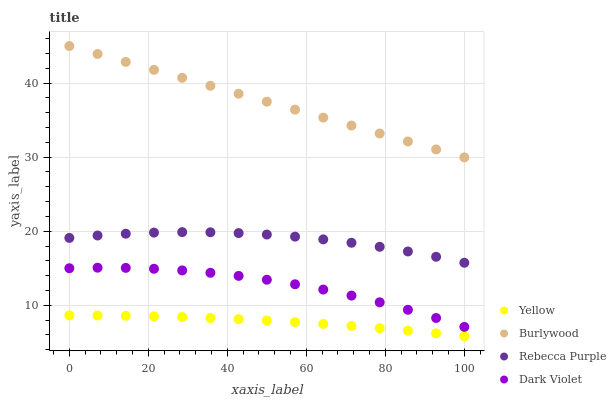Does Yellow have the minimum area under the curve?
Answer yes or no. Yes. Does Burlywood have the maximum area under the curve?
Answer yes or no. Yes. Does Dark Violet have the minimum area under the curve?
Answer yes or no. No. Does Dark Violet have the maximum area under the curve?
Answer yes or no. No. Is Burlywood the smoothest?
Answer yes or no. Yes. Is Dark Violet the roughest?
Answer yes or no. Yes. Is Rebecca Purple the smoothest?
Answer yes or no. No. Is Rebecca Purple the roughest?
Answer yes or no. No. Does Yellow have the lowest value?
Answer yes or no. Yes. Does Dark Violet have the lowest value?
Answer yes or no. No. Does Burlywood have the highest value?
Answer yes or no. Yes. Does Dark Violet have the highest value?
Answer yes or no. No. Is Dark Violet less than Rebecca Purple?
Answer yes or no. Yes. Is Burlywood greater than Yellow?
Answer yes or no. Yes. Does Dark Violet intersect Rebecca Purple?
Answer yes or no. No. 